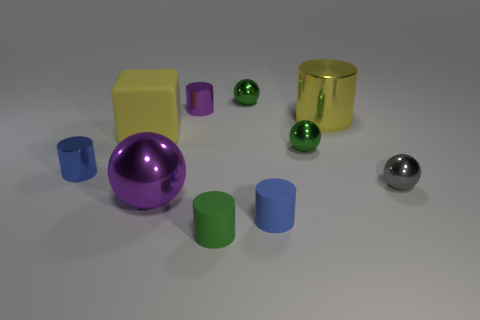Subtract all purple cylinders. How many cylinders are left? 4 Subtract all green cylinders. How many cylinders are left? 4 Subtract all gray cylinders. Subtract all cyan balls. How many cylinders are left? 5 Subtract all cubes. How many objects are left? 9 Subtract 0 blue spheres. How many objects are left? 10 Subtract all purple cylinders. Subtract all small gray metallic spheres. How many objects are left? 8 Add 4 tiny blue metal cylinders. How many tiny blue metal cylinders are left? 5 Add 10 tiny purple rubber things. How many tiny purple rubber things exist? 10 